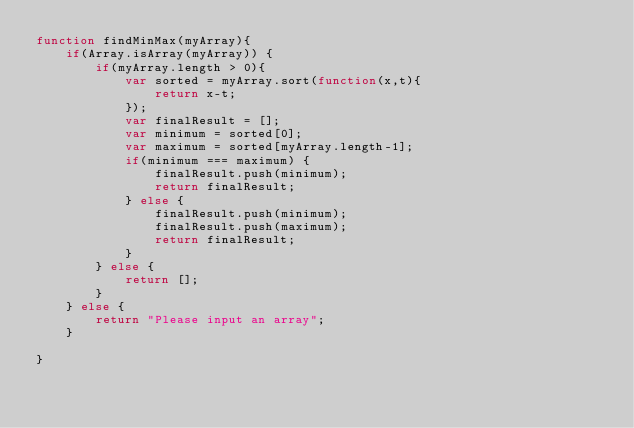<code> <loc_0><loc_0><loc_500><loc_500><_JavaScript_>function findMinMax(myArray){
	if(Array.isArray(myArray)) {
		if(myArray.length > 0){
			var sorted = myArray.sort(function(x,t){
				return x-t;
			});
			var finalResult = [];
			var minimum = sorted[0];
			var maximum = sorted[myArray.length-1];
			if(minimum === maximum) {
				finalResult.push(minimum);
				return finalResult;
			} else {
				finalResult.push(minimum);
				finalResult.push(maximum);
				return finalResult;
			}
		} else {
			return [];
		}
	} else {
		return "Please input an array";
	}
  
}</code> 